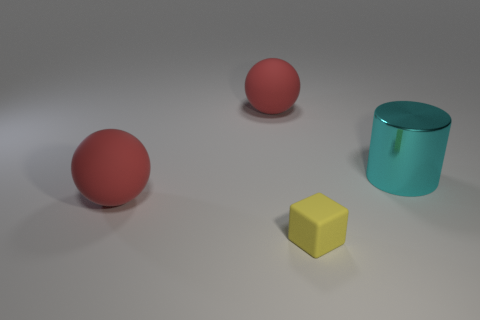What shape is the rubber object that is both behind the small yellow rubber block and in front of the cylinder?
Offer a terse response. Sphere. Is the size of the cyan metal thing the same as the yellow object?
Your answer should be compact. No. Are there fewer tiny yellow matte objects behind the tiny matte object than big shiny things right of the large cyan cylinder?
Provide a succinct answer. No. What size is the object that is both in front of the big cyan metallic cylinder and on the left side of the yellow rubber thing?
Ensure brevity in your answer.  Large. Is there a large shiny cylinder that is in front of the large ball that is in front of the red rubber thing behind the cyan metallic object?
Your answer should be compact. No. Are any small things visible?
Provide a short and direct response. Yes. Is the number of tiny things on the right side of the small matte object greater than the number of large red objects in front of the large cylinder?
Offer a terse response. No. What is the size of the red ball on the right side of the red rubber ball that is in front of the thing to the right of the block?
Give a very brief answer. Large. What color is the thing that is to the right of the small yellow rubber object?
Keep it short and to the point. Cyan. Is the number of things that are behind the large cyan cylinder greater than the number of blue matte blocks?
Provide a short and direct response. Yes. 